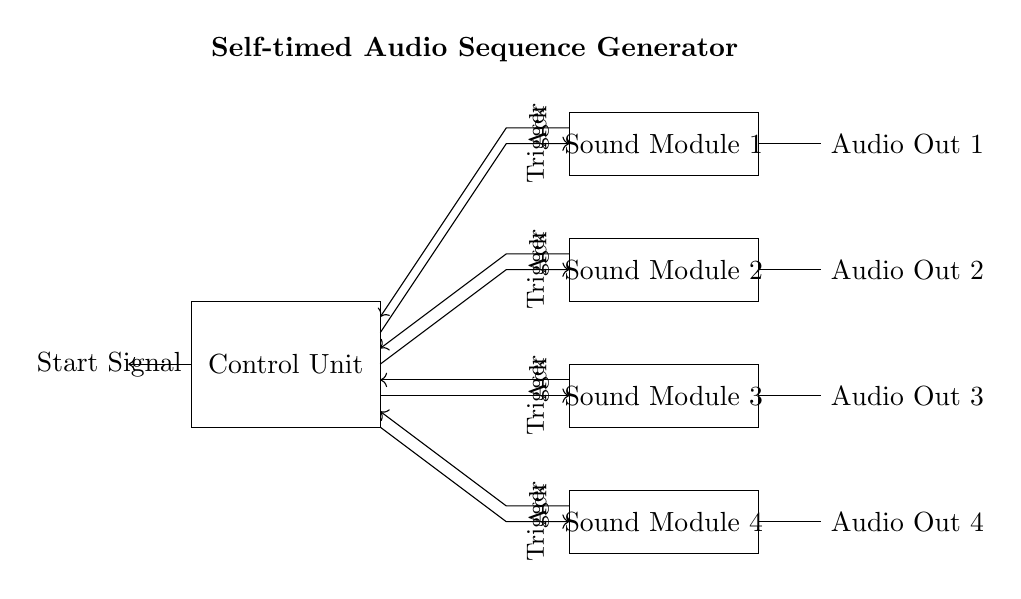What is the main component of this circuit? The main component, as labeled in the diagram, is the control unit, which manages the entire sequence of audio production.
Answer: Control Unit How many sound modules are present in this circuit? The diagram shows four distinct sound modules, each labeled and positioned separately.
Answer: Four What signal initiates the audio sequence? The circuit is triggered to start the sequence by the start signal, which is shown entering from the left side into the control unit.
Answer: Start Signal What do the arrows in the circuit indicate? The arrows represent the direction of signal flow between components, showing how each module and the control unit communicate with one another.
Answer: Signal Flow What type of circuit is represented by this diagram? This circuit is an asynchronous audio sequence generator, which means it operates independently of a clock signal and relies on triggers instead.
Answer: Asynchronous Which module receives its trigger from the control unit? Each sound module receives its triggering signal individually from the control unit, indicating that they can operate independently based on their respective triggers.
Answer: All Sound Modules What are the outputs of this circuit? The outputs are labeled as Audio Out 1, Audio Out 2, Audio Out 3, and Audio Out 4, providing audio signals from each of the sound modules for production.
Answer: Audio Out 1, Audio Out 2, Audio Out 3, Audio Out 4 